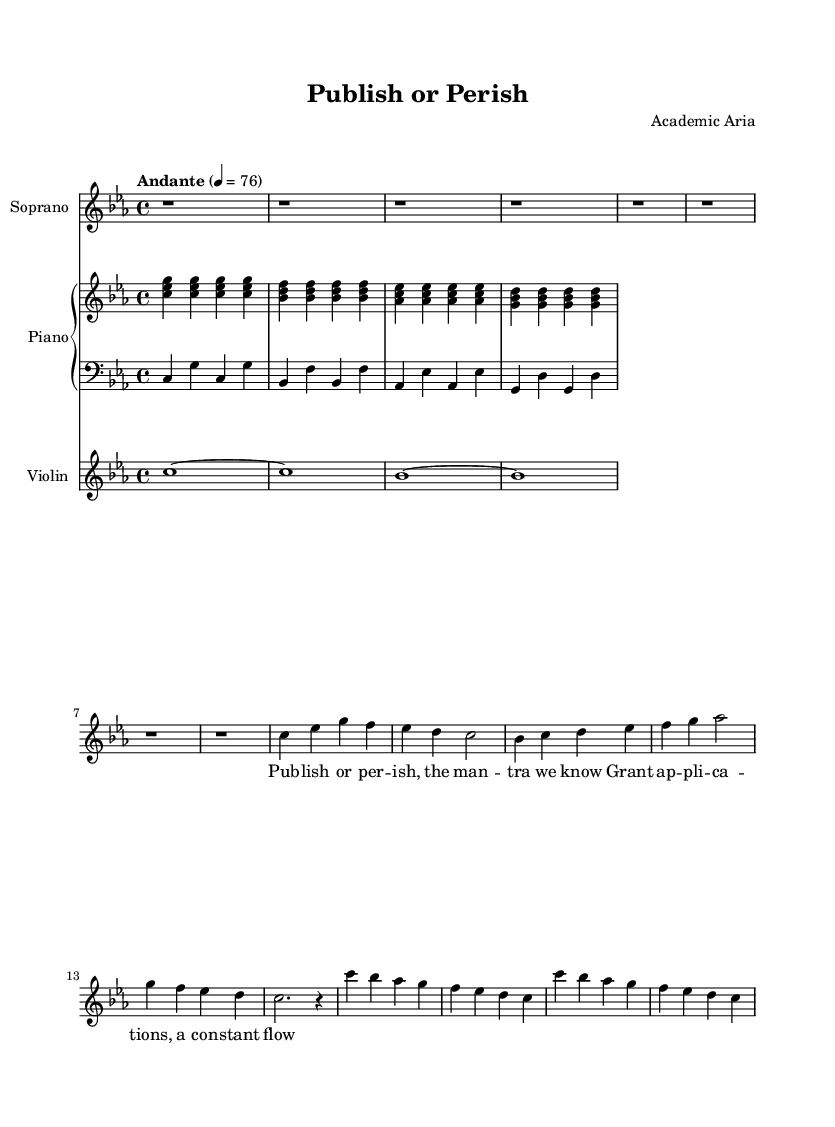What is the key signature of this music? The key signature is found in the global section at the beginning, where it is indicated as "c" with a minor label. This means the piece is in C minor, which has three flats.
Answer: C minor What is the time signature of this music? The time signature is found in the global section as well, indicated as "4/4", which means there are four beats in a measure and the quarter note receives one beat.
Answer: 4/4 What is the tempo marking of this music? The tempo marking is provided in the global section as "Andante" with a metronome marking of 76, indicating a moderately slow tempo.
Answer: Andante 4 = 76 How many measures are there in the main theme (Verse 1)? The main theme (Verse 1) consists of a total of six measures, which can be counted from the soprano part where each line represents a measure.
Answer: 6 What is the interval between the soprano's first and second notes in the main theme? The first note is C, and the second note is E-flat, which is a minor third apart. To determine the interval, we count the number of letter names from C to E (C-D-E) and determine it is a minor third since E-flat is the minor third above C.
Answer: Minor third How many notes are sung in the chorus section by the soprano? In the chorus section presented in the soprano part, there are a total of eight different sung notes revealed in the two lines of music, each with a single distinct pitch.
Answer: 8 What theme does the title "Publish or Perish" reflect regarding academia? The title "Publish or Perish" conveys the pressure faced by academics to produce research and publish their findings or risk losing their position, thus directly reflecting the overarching theme of stress in academia.
Answer: Academic pressure 